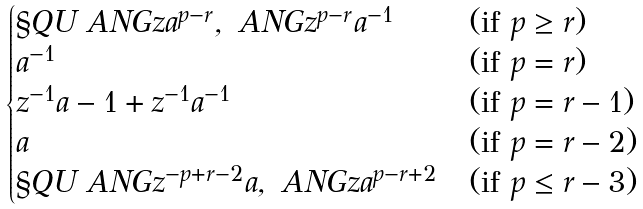<formula> <loc_0><loc_0><loc_500><loc_500>\begin{cases} \S Q U { \ A N G { z } a ^ { p - r } , \ A N G { z ^ { p - r } } a ^ { - 1 } } & ( \text {if\/ } p \geq r ) \\ a ^ { - 1 } & ( \text {if\/ } p = r ) \\ z ^ { - 1 } a - 1 + z ^ { - 1 } a ^ { - 1 } & ( \text {if\/ } p = r - 1 ) \\ a & ( \text {if\/ } p = r - 2 ) \\ \S Q U { \ A N G { z ^ { - p + r - 2 } } a , \ A N G { z } a ^ { p - r + 2 } } & ( \text {if\/ } p \leq r - 3 ) \\ \end{cases}</formula> 